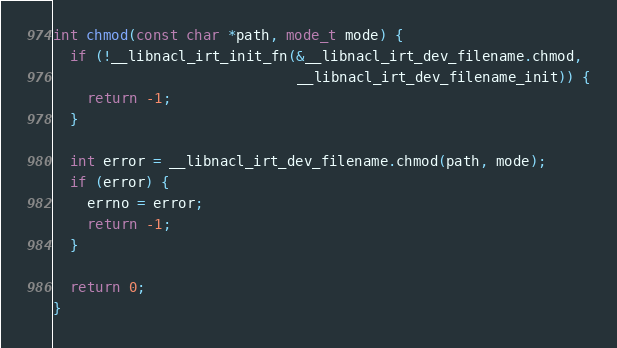Convert code to text. <code><loc_0><loc_0><loc_500><loc_500><_C_>
int chmod(const char *path, mode_t mode) {
  if (!__libnacl_irt_init_fn(&__libnacl_irt_dev_filename.chmod,
                             __libnacl_irt_dev_filename_init)) {
    return -1;
  }

  int error = __libnacl_irt_dev_filename.chmod(path, mode);
  if (error) {
    errno = error;
    return -1;
  }

  return 0;
}
</code> 